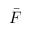<formula> <loc_0><loc_0><loc_500><loc_500>\bar { F }</formula> 